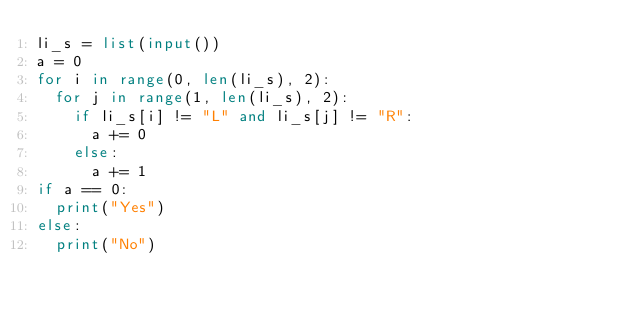<code> <loc_0><loc_0><loc_500><loc_500><_Python_>li_s = list(input())
a = 0
for i in range(0, len(li_s), 2):
  for j in range(1, len(li_s), 2):
    if li_s[i] != "L" and li_s[j] != "R":
      a += 0
    else:
      a += 1
if a == 0:
  print("Yes")
else:
  print("No")</code> 